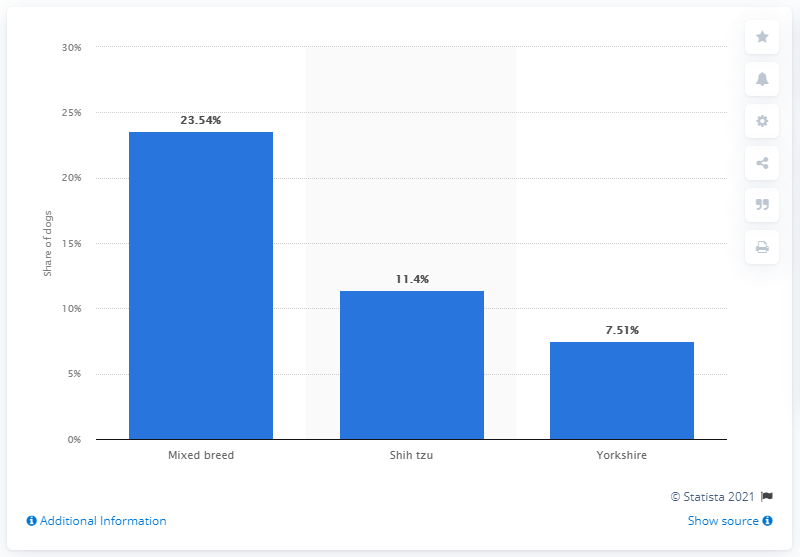List a handful of essential elements in this visual. The Shih Tzu is the second most popular type of dog in Brazil. According to a recent survey in Brazil, mixed breed dogs make up 23.54% of all dogs owned in the country. 